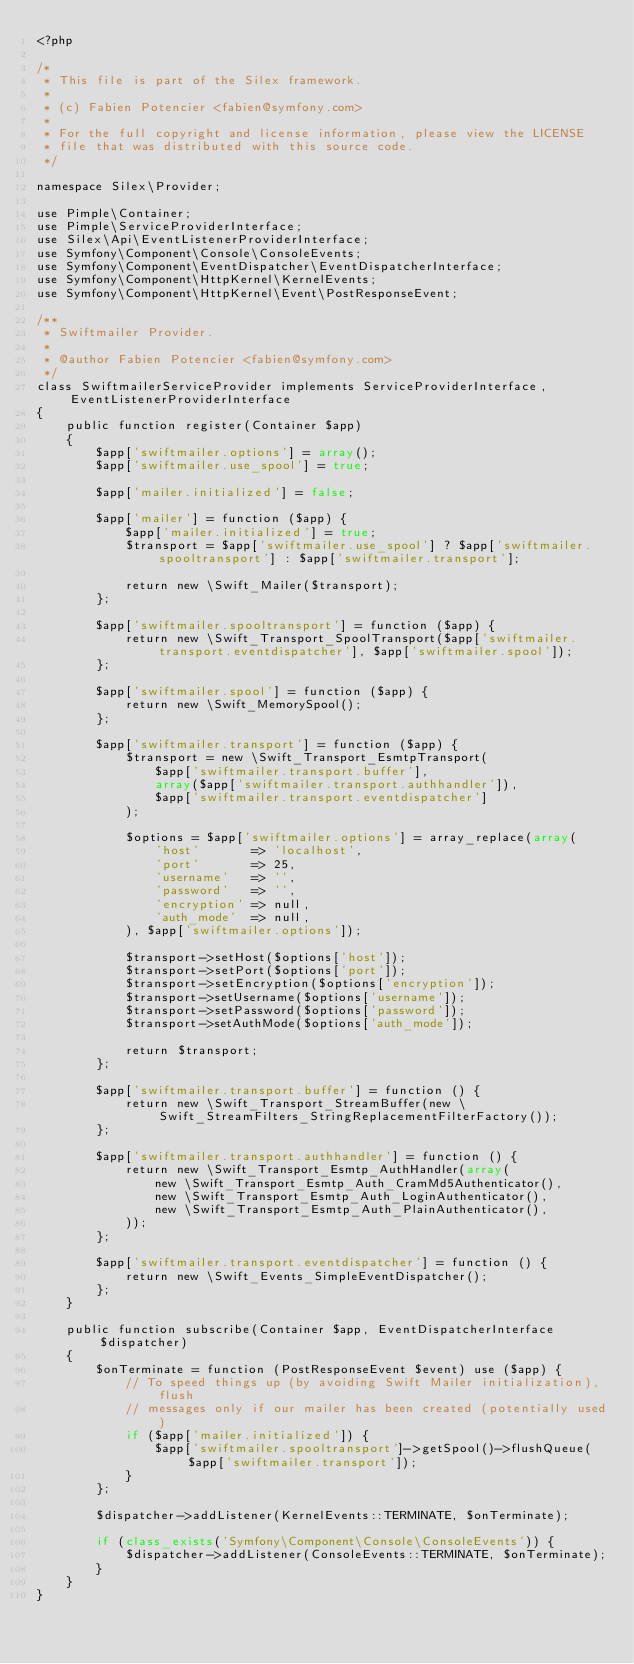Convert code to text. <code><loc_0><loc_0><loc_500><loc_500><_PHP_><?php

/*
 * This file is part of the Silex framework.
 *
 * (c) Fabien Potencier <fabien@symfony.com>
 *
 * For the full copyright and license information, please view the LICENSE
 * file that was distributed with this source code.
 */

namespace Silex\Provider;

use Pimple\Container;
use Pimple\ServiceProviderInterface;
use Silex\Api\EventListenerProviderInterface;
use Symfony\Component\Console\ConsoleEvents;
use Symfony\Component\EventDispatcher\EventDispatcherInterface;
use Symfony\Component\HttpKernel\KernelEvents;
use Symfony\Component\HttpKernel\Event\PostResponseEvent;

/**
 * Swiftmailer Provider.
 *
 * @author Fabien Potencier <fabien@symfony.com>
 */
class SwiftmailerServiceProvider implements ServiceProviderInterface, EventListenerProviderInterface
{
    public function register(Container $app)
    {
        $app['swiftmailer.options'] = array();
        $app['swiftmailer.use_spool'] = true;

        $app['mailer.initialized'] = false;

        $app['mailer'] = function ($app) {
            $app['mailer.initialized'] = true;
            $transport = $app['swiftmailer.use_spool'] ? $app['swiftmailer.spooltransport'] : $app['swiftmailer.transport'];

            return new \Swift_Mailer($transport);
        };

        $app['swiftmailer.spooltransport'] = function ($app) {
            return new \Swift_Transport_SpoolTransport($app['swiftmailer.transport.eventdispatcher'], $app['swiftmailer.spool']);
        };

        $app['swiftmailer.spool'] = function ($app) {
            return new \Swift_MemorySpool();
        };

        $app['swiftmailer.transport'] = function ($app) {
            $transport = new \Swift_Transport_EsmtpTransport(
                $app['swiftmailer.transport.buffer'],
                array($app['swiftmailer.transport.authhandler']),
                $app['swiftmailer.transport.eventdispatcher']
            );

            $options = $app['swiftmailer.options'] = array_replace(array(
                'host'       => 'localhost',
                'port'       => 25,
                'username'   => '',
                'password'   => '',
                'encryption' => null,
                'auth_mode'  => null,
            ), $app['swiftmailer.options']);

            $transport->setHost($options['host']);
            $transport->setPort($options['port']);
            $transport->setEncryption($options['encryption']);
            $transport->setUsername($options['username']);
            $transport->setPassword($options['password']);
            $transport->setAuthMode($options['auth_mode']);

            return $transport;
        };

        $app['swiftmailer.transport.buffer'] = function () {
            return new \Swift_Transport_StreamBuffer(new \Swift_StreamFilters_StringReplacementFilterFactory());
        };

        $app['swiftmailer.transport.authhandler'] = function () {
            return new \Swift_Transport_Esmtp_AuthHandler(array(
                new \Swift_Transport_Esmtp_Auth_CramMd5Authenticator(),
                new \Swift_Transport_Esmtp_Auth_LoginAuthenticator(),
                new \Swift_Transport_Esmtp_Auth_PlainAuthenticator(),
            ));
        };

        $app['swiftmailer.transport.eventdispatcher'] = function () {
            return new \Swift_Events_SimpleEventDispatcher();
        };
    }

    public function subscribe(Container $app, EventDispatcherInterface $dispatcher)
    {
        $onTerminate = function (PostResponseEvent $event) use ($app) {
            // To speed things up (by avoiding Swift Mailer initialization), flush
            // messages only if our mailer has been created (potentially used)
            if ($app['mailer.initialized']) {
                $app['swiftmailer.spooltransport']->getSpool()->flushQueue($app['swiftmailer.transport']);
            }
        };

        $dispatcher->addListener(KernelEvents::TERMINATE, $onTerminate);

        if (class_exists('Symfony\Component\Console\ConsoleEvents')) {
            $dispatcher->addListener(ConsoleEvents::TERMINATE, $onTerminate);
        }
    }
}
</code> 